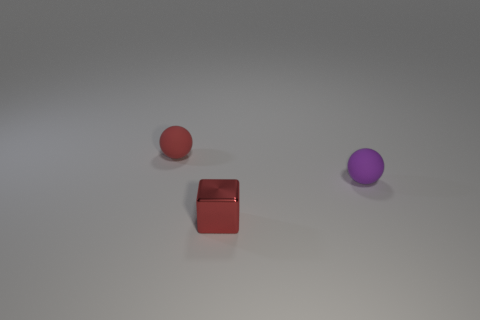Add 3 tiny green cylinders. How many objects exist? 6 Subtract all balls. How many objects are left? 1 Add 1 tiny gray metallic cubes. How many tiny gray metallic cubes exist? 1 Subtract 0 brown spheres. How many objects are left? 3 Subtract all purple rubber balls. Subtract all purple rubber things. How many objects are left? 1 Add 2 small red rubber things. How many small red rubber things are left? 3 